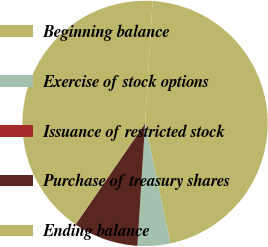Convert chart. <chart><loc_0><loc_0><loc_500><loc_500><pie_chart><fcel>Beginning balance<fcel>Exercise of stock options<fcel>Issuance of restricted stock<fcel>Purchase of treasury shares<fcel>Ending balance<nl><fcel>45.7%<fcel>4.3%<fcel>0.01%<fcel>8.59%<fcel>41.4%<nl></chart> 